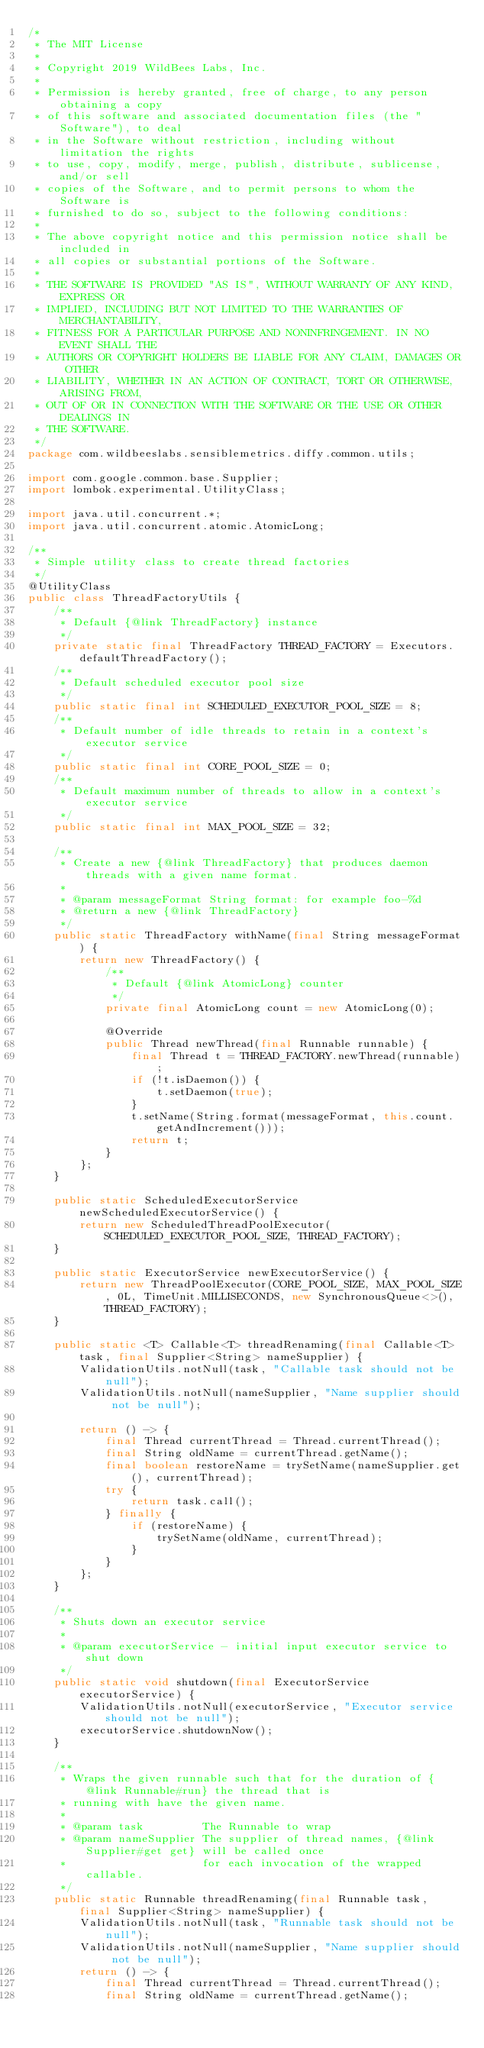Convert code to text. <code><loc_0><loc_0><loc_500><loc_500><_Java_>/*
 * The MIT License
 *
 * Copyright 2019 WildBees Labs, Inc.
 *
 * Permission is hereby granted, free of charge, to any person obtaining a copy
 * of this software and associated documentation files (the "Software"), to deal
 * in the Software without restriction, including without limitation the rights
 * to use, copy, modify, merge, publish, distribute, sublicense, and/or sell
 * copies of the Software, and to permit persons to whom the Software is
 * furnished to do so, subject to the following conditions:
 *
 * The above copyright notice and this permission notice shall be included in
 * all copies or substantial portions of the Software.
 *
 * THE SOFTWARE IS PROVIDED "AS IS", WITHOUT WARRANTY OF ANY KIND, EXPRESS OR
 * IMPLIED, INCLUDING BUT NOT LIMITED TO THE WARRANTIES OF MERCHANTABILITY,
 * FITNESS FOR A PARTICULAR PURPOSE AND NONINFRINGEMENT. IN NO EVENT SHALL THE
 * AUTHORS OR COPYRIGHT HOLDERS BE LIABLE FOR ANY CLAIM, DAMAGES OR OTHER
 * LIABILITY, WHETHER IN AN ACTION OF CONTRACT, TORT OR OTHERWISE, ARISING FROM,
 * OUT OF OR IN CONNECTION WITH THE SOFTWARE OR THE USE OR OTHER DEALINGS IN
 * THE SOFTWARE.
 */
package com.wildbeeslabs.sensiblemetrics.diffy.common.utils;

import com.google.common.base.Supplier;
import lombok.experimental.UtilityClass;

import java.util.concurrent.*;
import java.util.concurrent.atomic.AtomicLong;

/**
 * Simple utility class to create thread factories
 */
@UtilityClass
public class ThreadFactoryUtils {
    /**
     * Default {@link ThreadFactory} instance
     */
    private static final ThreadFactory THREAD_FACTORY = Executors.defaultThreadFactory();
    /**
     * Default scheduled executor pool size
     */
    public static final int SCHEDULED_EXECUTOR_POOL_SIZE = 8;
    /**
     * Default number of idle threads to retain in a context's executor service
     */
    public static final int CORE_POOL_SIZE = 0;
    /**
     * Default maximum number of threads to allow in a context's executor service
     */
    public static final int MAX_POOL_SIZE = 32;

    /**
     * Create a new {@link ThreadFactory} that produces daemon threads with a given name format.
     *
     * @param messageFormat String format: for example foo-%d
     * @return a new {@link ThreadFactory}
     */
    public static ThreadFactory withName(final String messageFormat) {
        return new ThreadFactory() {
            /**
             * Default {@link AtomicLong} counter
             */
            private final AtomicLong count = new AtomicLong(0);

            @Override
            public Thread newThread(final Runnable runnable) {
                final Thread t = THREAD_FACTORY.newThread(runnable);
                if (!t.isDaemon()) {
                    t.setDaemon(true);
                }
                t.setName(String.format(messageFormat, this.count.getAndIncrement()));
                return t;
            }
        };
    }

    public static ScheduledExecutorService newScheduledExecutorService() {
        return new ScheduledThreadPoolExecutor(SCHEDULED_EXECUTOR_POOL_SIZE, THREAD_FACTORY);
    }

    public static ExecutorService newExecutorService() {
        return new ThreadPoolExecutor(CORE_POOL_SIZE, MAX_POOL_SIZE, 0L, TimeUnit.MILLISECONDS, new SynchronousQueue<>(), THREAD_FACTORY);
    }

    public static <T> Callable<T> threadRenaming(final Callable<T> task, final Supplier<String> nameSupplier) {
        ValidationUtils.notNull(task, "Callable task should not be null");
        ValidationUtils.notNull(nameSupplier, "Name supplier should not be null");

        return () -> {
            final Thread currentThread = Thread.currentThread();
            final String oldName = currentThread.getName();
            final boolean restoreName = trySetName(nameSupplier.get(), currentThread);
            try {
                return task.call();
            } finally {
                if (restoreName) {
                    trySetName(oldName, currentThread);
                }
            }
        };
    }

    /**
     * Shuts down an executor service
     *
     * @param executorService - initial input executor service to shut down
     */
    public static void shutdown(final ExecutorService executorService) {
        ValidationUtils.notNull(executorService, "Executor service should not be null");
        executorService.shutdownNow();
    }

    /**
     * Wraps the given runnable such that for the duration of {@link Runnable#run} the thread that is
     * running with have the given name.
     *
     * @param task         The Runnable to wrap
     * @param nameSupplier The supplier of thread names, {@link Supplier#get get} will be called once
     *                     for each invocation of the wrapped callable.
     */
    public static Runnable threadRenaming(final Runnable task, final Supplier<String> nameSupplier) {
        ValidationUtils.notNull(task, "Runnable task should not be null");
        ValidationUtils.notNull(nameSupplier, "Name supplier should not be null");
        return () -> {
            final Thread currentThread = Thread.currentThread();
            final String oldName = currentThread.getName();</code> 